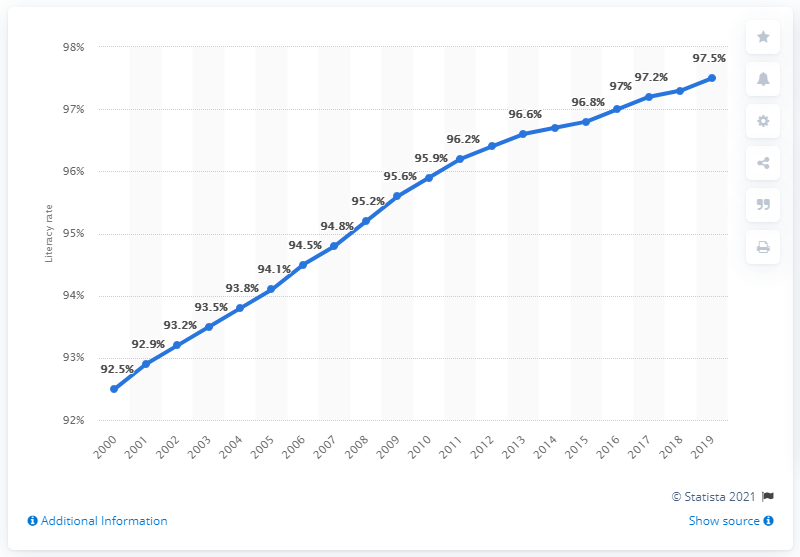Draw attention to some important aspects in this diagram. In 2019, the literacy rate for individuals aged 15 and older in Singapore was 97.5%. 